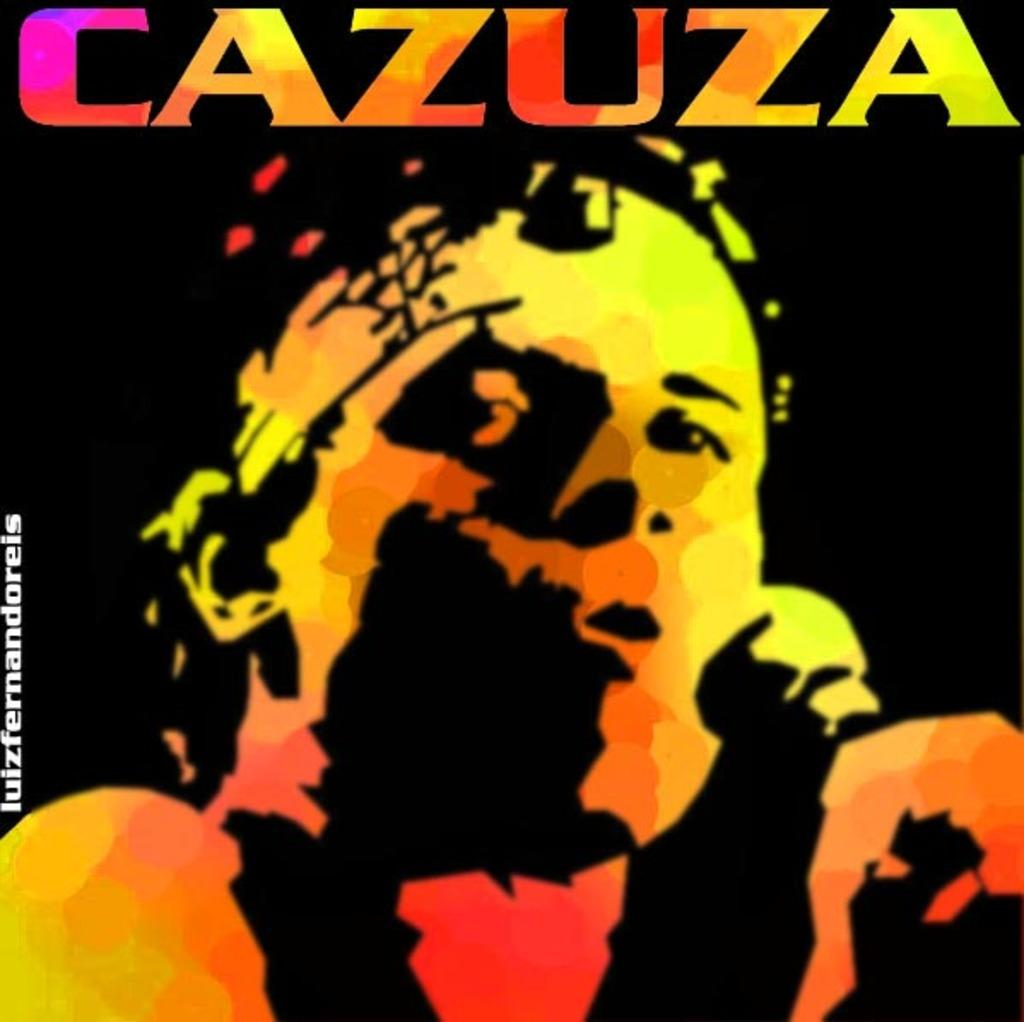<image>
Share a concise interpretation of the image provided. A Cazuza album has a man on it in black and neon colors. 